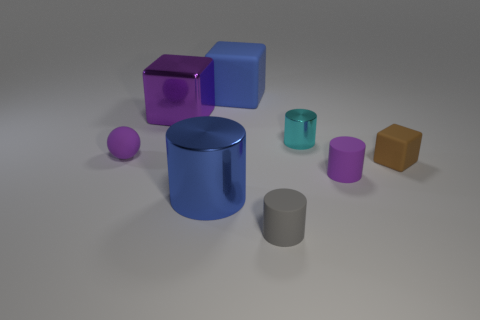Add 2 small green cylinders. How many objects exist? 10 Subtract all yellow cylinders. Subtract all brown balls. How many cylinders are left? 4 Subtract all cubes. How many objects are left? 5 Add 1 blue things. How many blue things are left? 3 Add 4 tiny brown matte things. How many tiny brown matte things exist? 5 Subtract 1 brown blocks. How many objects are left? 7 Subtract all big blue metal cylinders. Subtract all big metal blocks. How many objects are left? 6 